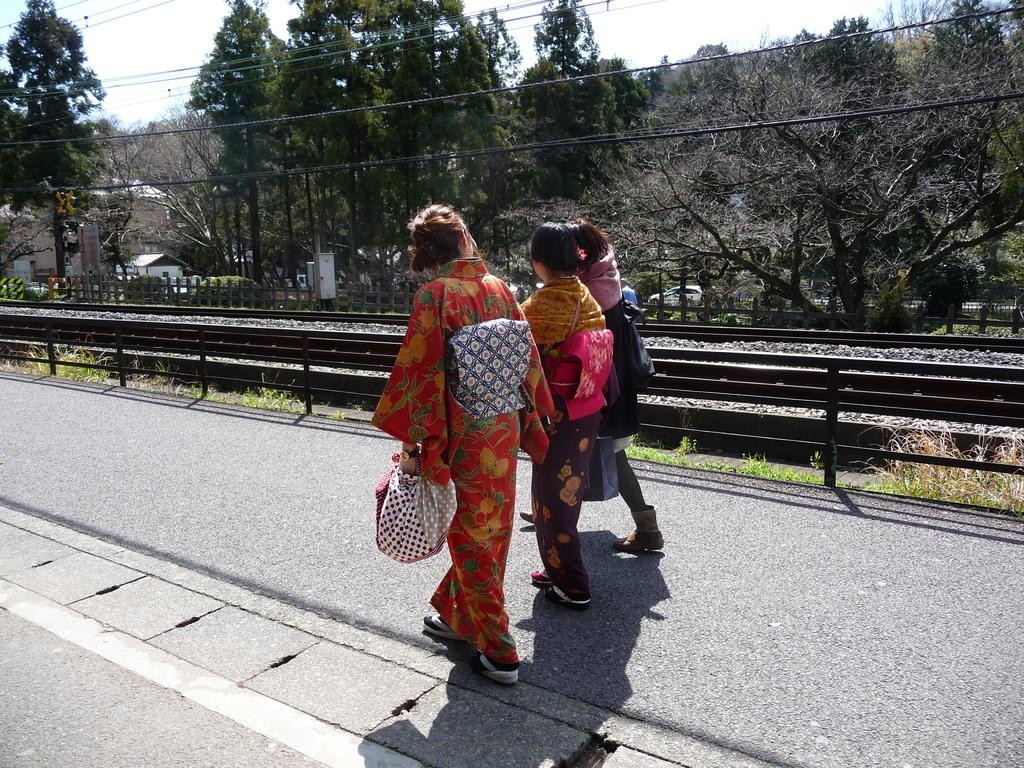What are the people in the image doing? The people in the image are walking. What is at the bottom of the image? There is a road at the bottom of the image. What can be seen in the background of the image? There are trees in the background of the image. What other transportation feature is present in the image? There are railway tracks in the image. What type of egg is being used to make the soda in the image? There is no egg or soda present in the image; it features people walking, a road, trees, and railway tracks. How many pies are visible on the railway tracks in the image? There are no pies present on the railway tracks or anywhere else in the image. 